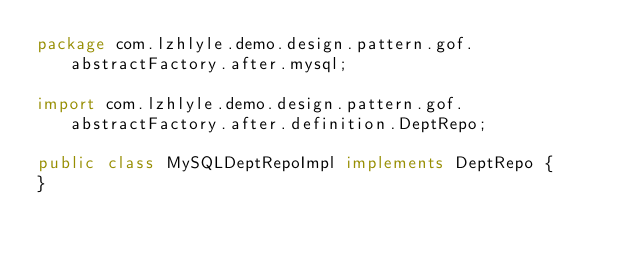Convert code to text. <code><loc_0><loc_0><loc_500><loc_500><_Java_>package com.lzhlyle.demo.design.pattern.gof.abstractFactory.after.mysql;

import com.lzhlyle.demo.design.pattern.gof.abstractFactory.after.definition.DeptRepo;

public class MySQLDeptRepoImpl implements DeptRepo {
}
</code> 